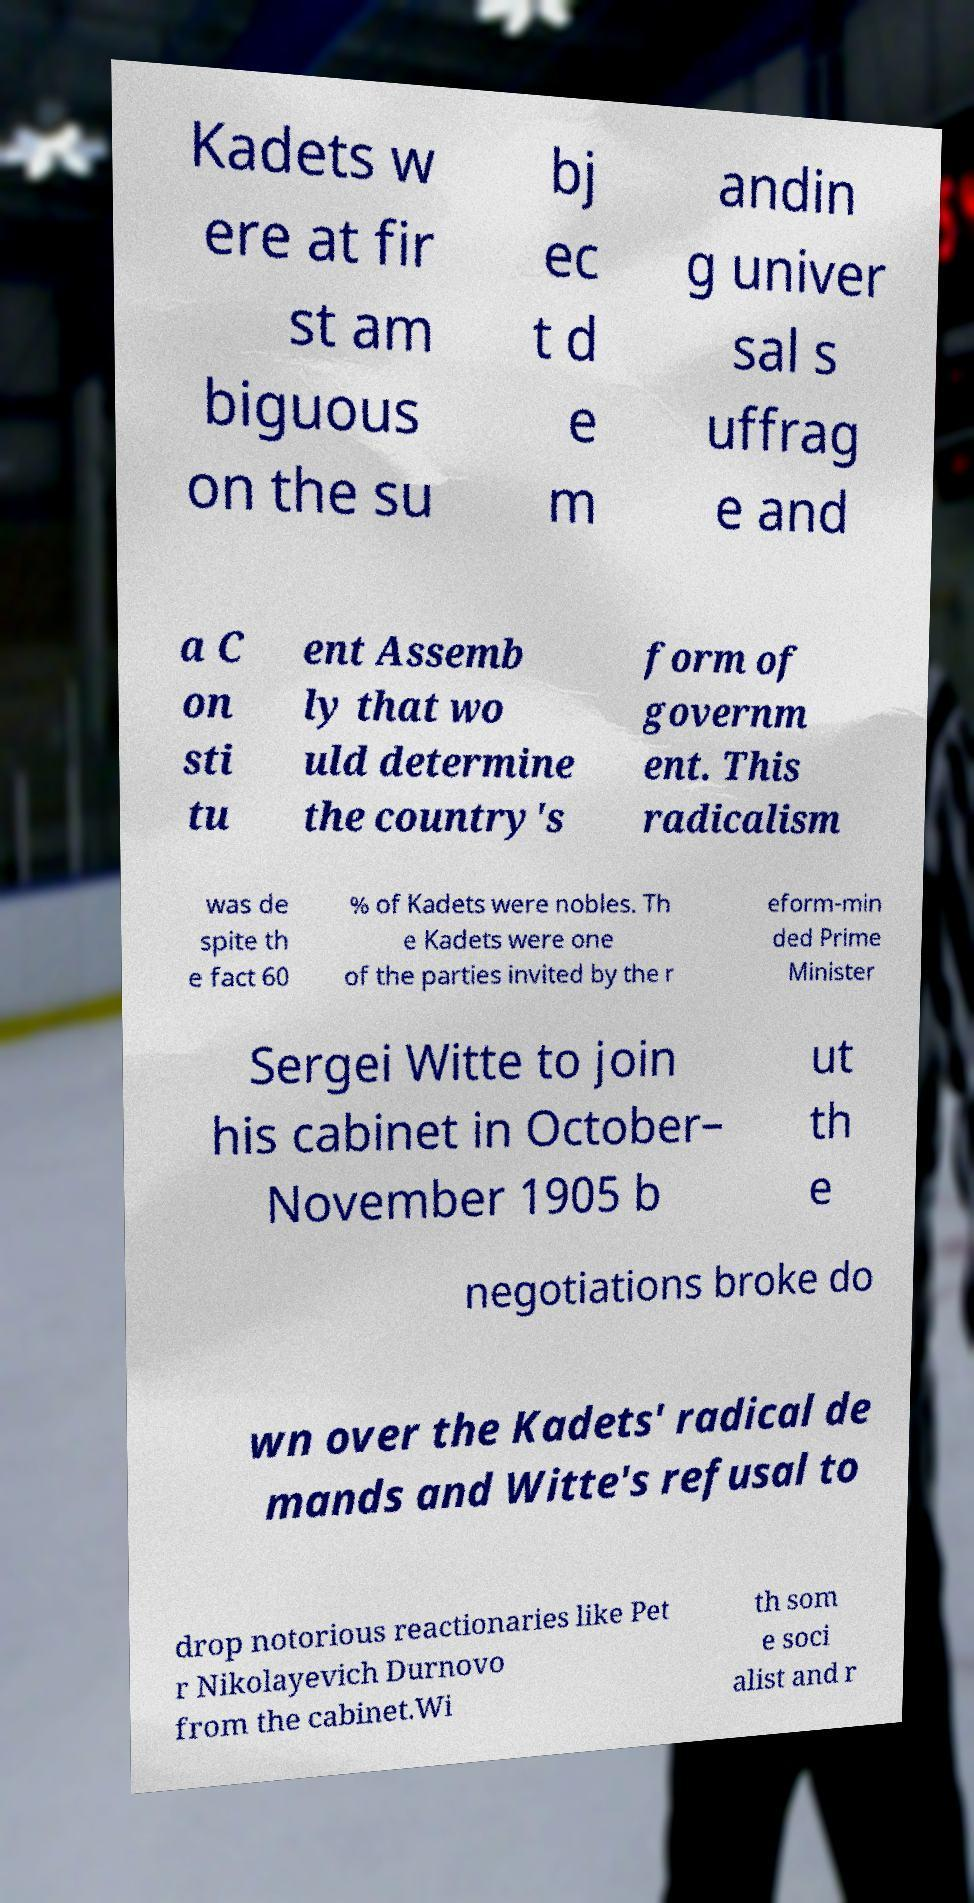Could you assist in decoding the text presented in this image and type it out clearly? Kadets w ere at fir st am biguous on the su bj ec t d e m andin g univer sal s uffrag e and a C on sti tu ent Assemb ly that wo uld determine the country's form of governm ent. This radicalism was de spite th e fact 60 % of Kadets were nobles. Th e Kadets were one of the parties invited by the r eform-min ded Prime Minister Sergei Witte to join his cabinet in October– November 1905 b ut th e negotiations broke do wn over the Kadets' radical de mands and Witte's refusal to drop notorious reactionaries like Pet r Nikolayevich Durnovo from the cabinet.Wi th som e soci alist and r 